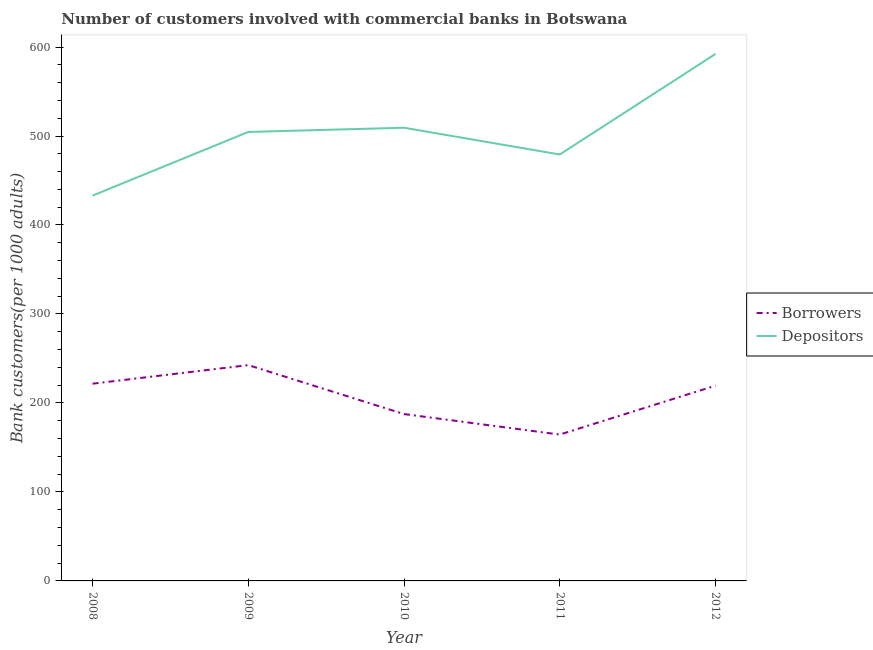How many different coloured lines are there?
Offer a very short reply. 2. What is the number of depositors in 2012?
Provide a short and direct response. 592.26. Across all years, what is the maximum number of depositors?
Keep it short and to the point. 592.26. Across all years, what is the minimum number of depositors?
Your answer should be very brief. 433.02. In which year was the number of borrowers minimum?
Offer a terse response. 2011. What is the total number of depositors in the graph?
Provide a short and direct response. 2518.35. What is the difference between the number of borrowers in 2009 and that in 2012?
Give a very brief answer. 23.08. What is the difference between the number of borrowers in 2011 and the number of depositors in 2012?
Provide a short and direct response. -427.78. What is the average number of depositors per year?
Provide a succinct answer. 503.67. In the year 2009, what is the difference between the number of borrowers and number of depositors?
Your answer should be compact. -262.03. In how many years, is the number of borrowers greater than 420?
Make the answer very short. 0. What is the ratio of the number of borrowers in 2010 to that in 2012?
Make the answer very short. 0.85. Is the difference between the number of borrowers in 2008 and 2009 greater than the difference between the number of depositors in 2008 and 2009?
Provide a succinct answer. Yes. What is the difference between the highest and the second highest number of borrowers?
Make the answer very short. 20.87. What is the difference between the highest and the lowest number of depositors?
Keep it short and to the point. 159.25. Is the sum of the number of borrowers in 2010 and 2012 greater than the maximum number of depositors across all years?
Keep it short and to the point. No. Is the number of depositors strictly greater than the number of borrowers over the years?
Offer a terse response. Yes. What is the difference between two consecutive major ticks on the Y-axis?
Your answer should be very brief. 100. Does the graph contain grids?
Your answer should be compact. No. Where does the legend appear in the graph?
Provide a short and direct response. Center right. How many legend labels are there?
Your response must be concise. 2. What is the title of the graph?
Provide a short and direct response. Number of customers involved with commercial banks in Botswana. What is the label or title of the Y-axis?
Your answer should be compact. Bank customers(per 1000 adults). What is the Bank customers(per 1000 adults) of Borrowers in 2008?
Your answer should be very brief. 221.65. What is the Bank customers(per 1000 adults) in Depositors in 2008?
Provide a short and direct response. 433.02. What is the Bank customers(per 1000 adults) of Borrowers in 2009?
Ensure brevity in your answer.  242.52. What is the Bank customers(per 1000 adults) in Depositors in 2009?
Your answer should be very brief. 504.55. What is the Bank customers(per 1000 adults) of Borrowers in 2010?
Keep it short and to the point. 187.53. What is the Bank customers(per 1000 adults) in Depositors in 2010?
Keep it short and to the point. 509.3. What is the Bank customers(per 1000 adults) of Borrowers in 2011?
Keep it short and to the point. 164.48. What is the Bank customers(per 1000 adults) in Depositors in 2011?
Keep it short and to the point. 479.22. What is the Bank customers(per 1000 adults) in Borrowers in 2012?
Your answer should be very brief. 219.44. What is the Bank customers(per 1000 adults) in Depositors in 2012?
Offer a terse response. 592.26. Across all years, what is the maximum Bank customers(per 1000 adults) of Borrowers?
Give a very brief answer. 242.52. Across all years, what is the maximum Bank customers(per 1000 adults) in Depositors?
Give a very brief answer. 592.26. Across all years, what is the minimum Bank customers(per 1000 adults) in Borrowers?
Offer a very short reply. 164.48. Across all years, what is the minimum Bank customers(per 1000 adults) of Depositors?
Provide a succinct answer. 433.02. What is the total Bank customers(per 1000 adults) of Borrowers in the graph?
Offer a terse response. 1035.62. What is the total Bank customers(per 1000 adults) in Depositors in the graph?
Ensure brevity in your answer.  2518.35. What is the difference between the Bank customers(per 1000 adults) of Borrowers in 2008 and that in 2009?
Provide a succinct answer. -20.87. What is the difference between the Bank customers(per 1000 adults) of Depositors in 2008 and that in 2009?
Your answer should be very brief. -71.53. What is the difference between the Bank customers(per 1000 adults) of Borrowers in 2008 and that in 2010?
Provide a succinct answer. 34.12. What is the difference between the Bank customers(per 1000 adults) of Depositors in 2008 and that in 2010?
Ensure brevity in your answer.  -76.28. What is the difference between the Bank customers(per 1000 adults) in Borrowers in 2008 and that in 2011?
Ensure brevity in your answer.  57.17. What is the difference between the Bank customers(per 1000 adults) of Depositors in 2008 and that in 2011?
Offer a very short reply. -46.21. What is the difference between the Bank customers(per 1000 adults) of Borrowers in 2008 and that in 2012?
Make the answer very short. 2.21. What is the difference between the Bank customers(per 1000 adults) in Depositors in 2008 and that in 2012?
Offer a very short reply. -159.25. What is the difference between the Bank customers(per 1000 adults) in Borrowers in 2009 and that in 2010?
Provide a short and direct response. 55. What is the difference between the Bank customers(per 1000 adults) in Depositors in 2009 and that in 2010?
Keep it short and to the point. -4.75. What is the difference between the Bank customers(per 1000 adults) of Borrowers in 2009 and that in 2011?
Provide a short and direct response. 78.04. What is the difference between the Bank customers(per 1000 adults) of Depositors in 2009 and that in 2011?
Give a very brief answer. 25.33. What is the difference between the Bank customers(per 1000 adults) in Borrowers in 2009 and that in 2012?
Offer a very short reply. 23.08. What is the difference between the Bank customers(per 1000 adults) of Depositors in 2009 and that in 2012?
Provide a succinct answer. -87.71. What is the difference between the Bank customers(per 1000 adults) of Borrowers in 2010 and that in 2011?
Your answer should be very brief. 23.05. What is the difference between the Bank customers(per 1000 adults) in Depositors in 2010 and that in 2011?
Your response must be concise. 30.08. What is the difference between the Bank customers(per 1000 adults) of Borrowers in 2010 and that in 2012?
Offer a terse response. -31.91. What is the difference between the Bank customers(per 1000 adults) in Depositors in 2010 and that in 2012?
Provide a succinct answer. -82.96. What is the difference between the Bank customers(per 1000 adults) in Borrowers in 2011 and that in 2012?
Provide a succinct answer. -54.96. What is the difference between the Bank customers(per 1000 adults) in Depositors in 2011 and that in 2012?
Your answer should be very brief. -113.04. What is the difference between the Bank customers(per 1000 adults) of Borrowers in 2008 and the Bank customers(per 1000 adults) of Depositors in 2009?
Offer a terse response. -282.9. What is the difference between the Bank customers(per 1000 adults) of Borrowers in 2008 and the Bank customers(per 1000 adults) of Depositors in 2010?
Your answer should be compact. -287.65. What is the difference between the Bank customers(per 1000 adults) in Borrowers in 2008 and the Bank customers(per 1000 adults) in Depositors in 2011?
Ensure brevity in your answer.  -257.57. What is the difference between the Bank customers(per 1000 adults) in Borrowers in 2008 and the Bank customers(per 1000 adults) in Depositors in 2012?
Your answer should be very brief. -370.61. What is the difference between the Bank customers(per 1000 adults) in Borrowers in 2009 and the Bank customers(per 1000 adults) in Depositors in 2010?
Provide a short and direct response. -266.78. What is the difference between the Bank customers(per 1000 adults) in Borrowers in 2009 and the Bank customers(per 1000 adults) in Depositors in 2011?
Offer a terse response. -236.7. What is the difference between the Bank customers(per 1000 adults) in Borrowers in 2009 and the Bank customers(per 1000 adults) in Depositors in 2012?
Your answer should be compact. -349.74. What is the difference between the Bank customers(per 1000 adults) of Borrowers in 2010 and the Bank customers(per 1000 adults) of Depositors in 2011?
Offer a very short reply. -291.69. What is the difference between the Bank customers(per 1000 adults) of Borrowers in 2010 and the Bank customers(per 1000 adults) of Depositors in 2012?
Provide a short and direct response. -404.73. What is the difference between the Bank customers(per 1000 adults) of Borrowers in 2011 and the Bank customers(per 1000 adults) of Depositors in 2012?
Keep it short and to the point. -427.78. What is the average Bank customers(per 1000 adults) in Borrowers per year?
Ensure brevity in your answer.  207.12. What is the average Bank customers(per 1000 adults) of Depositors per year?
Your answer should be very brief. 503.67. In the year 2008, what is the difference between the Bank customers(per 1000 adults) in Borrowers and Bank customers(per 1000 adults) in Depositors?
Your response must be concise. -211.37. In the year 2009, what is the difference between the Bank customers(per 1000 adults) in Borrowers and Bank customers(per 1000 adults) in Depositors?
Give a very brief answer. -262.03. In the year 2010, what is the difference between the Bank customers(per 1000 adults) in Borrowers and Bank customers(per 1000 adults) in Depositors?
Make the answer very short. -321.77. In the year 2011, what is the difference between the Bank customers(per 1000 adults) of Borrowers and Bank customers(per 1000 adults) of Depositors?
Your answer should be very brief. -314.74. In the year 2012, what is the difference between the Bank customers(per 1000 adults) of Borrowers and Bank customers(per 1000 adults) of Depositors?
Give a very brief answer. -372.82. What is the ratio of the Bank customers(per 1000 adults) of Borrowers in 2008 to that in 2009?
Provide a succinct answer. 0.91. What is the ratio of the Bank customers(per 1000 adults) in Depositors in 2008 to that in 2009?
Provide a succinct answer. 0.86. What is the ratio of the Bank customers(per 1000 adults) in Borrowers in 2008 to that in 2010?
Provide a succinct answer. 1.18. What is the ratio of the Bank customers(per 1000 adults) in Depositors in 2008 to that in 2010?
Give a very brief answer. 0.85. What is the ratio of the Bank customers(per 1000 adults) in Borrowers in 2008 to that in 2011?
Your response must be concise. 1.35. What is the ratio of the Bank customers(per 1000 adults) of Depositors in 2008 to that in 2011?
Offer a very short reply. 0.9. What is the ratio of the Bank customers(per 1000 adults) of Borrowers in 2008 to that in 2012?
Ensure brevity in your answer.  1.01. What is the ratio of the Bank customers(per 1000 adults) of Depositors in 2008 to that in 2012?
Give a very brief answer. 0.73. What is the ratio of the Bank customers(per 1000 adults) in Borrowers in 2009 to that in 2010?
Your response must be concise. 1.29. What is the ratio of the Bank customers(per 1000 adults) of Depositors in 2009 to that in 2010?
Ensure brevity in your answer.  0.99. What is the ratio of the Bank customers(per 1000 adults) of Borrowers in 2009 to that in 2011?
Offer a very short reply. 1.47. What is the ratio of the Bank customers(per 1000 adults) of Depositors in 2009 to that in 2011?
Offer a very short reply. 1.05. What is the ratio of the Bank customers(per 1000 adults) in Borrowers in 2009 to that in 2012?
Give a very brief answer. 1.11. What is the ratio of the Bank customers(per 1000 adults) in Depositors in 2009 to that in 2012?
Provide a short and direct response. 0.85. What is the ratio of the Bank customers(per 1000 adults) in Borrowers in 2010 to that in 2011?
Your answer should be compact. 1.14. What is the ratio of the Bank customers(per 1000 adults) in Depositors in 2010 to that in 2011?
Your response must be concise. 1.06. What is the ratio of the Bank customers(per 1000 adults) in Borrowers in 2010 to that in 2012?
Your answer should be very brief. 0.85. What is the ratio of the Bank customers(per 1000 adults) in Depositors in 2010 to that in 2012?
Give a very brief answer. 0.86. What is the ratio of the Bank customers(per 1000 adults) of Borrowers in 2011 to that in 2012?
Your answer should be very brief. 0.75. What is the ratio of the Bank customers(per 1000 adults) in Depositors in 2011 to that in 2012?
Keep it short and to the point. 0.81. What is the difference between the highest and the second highest Bank customers(per 1000 adults) in Borrowers?
Ensure brevity in your answer.  20.87. What is the difference between the highest and the second highest Bank customers(per 1000 adults) of Depositors?
Provide a succinct answer. 82.96. What is the difference between the highest and the lowest Bank customers(per 1000 adults) in Borrowers?
Your answer should be very brief. 78.04. What is the difference between the highest and the lowest Bank customers(per 1000 adults) in Depositors?
Your answer should be very brief. 159.25. 